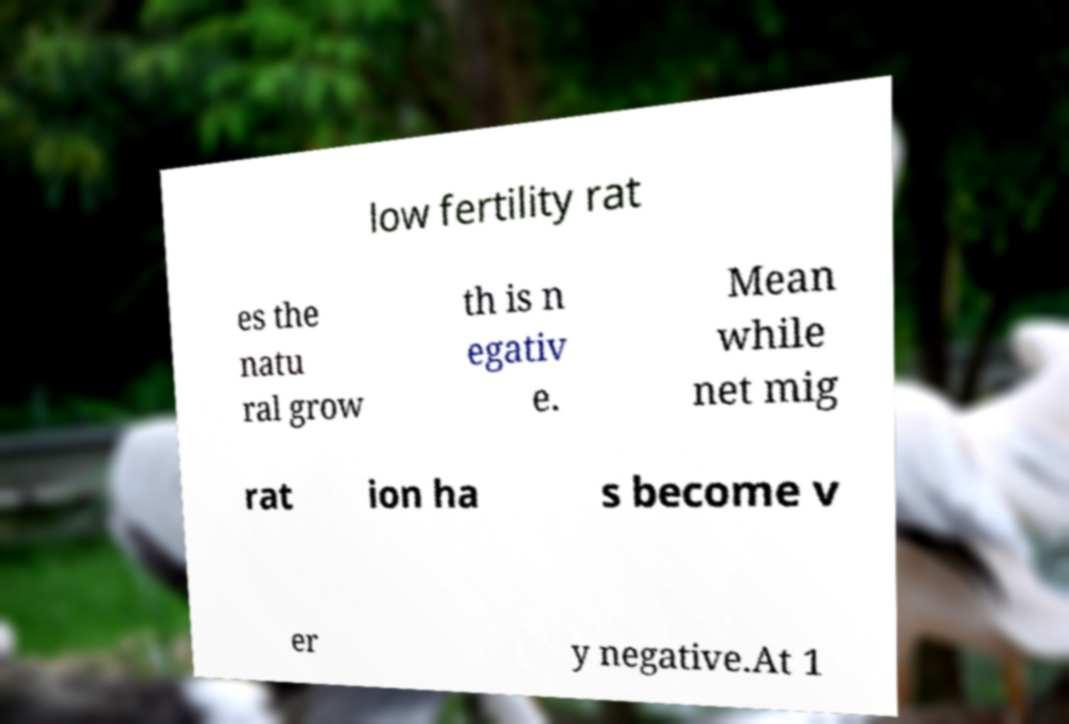Could you assist in decoding the text presented in this image and type it out clearly? low fertility rat es the natu ral grow th is n egativ e. Mean while net mig rat ion ha s become v er y negative.At 1 